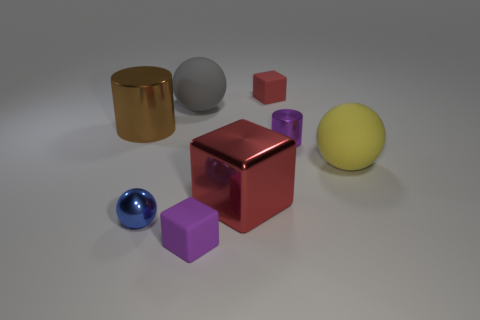Add 2 matte things. How many objects exist? 10 Subtract all cubes. How many objects are left? 5 Add 4 big yellow shiny cylinders. How many big yellow shiny cylinders exist? 4 Subtract 0 red cylinders. How many objects are left? 8 Subtract all large blocks. Subtract all small yellow metal spheres. How many objects are left? 7 Add 2 yellow balls. How many yellow balls are left? 3 